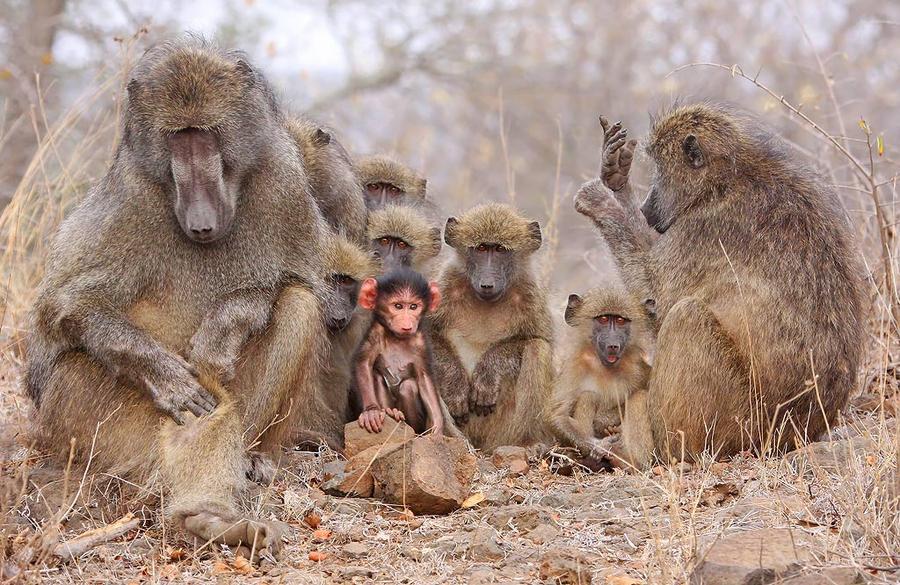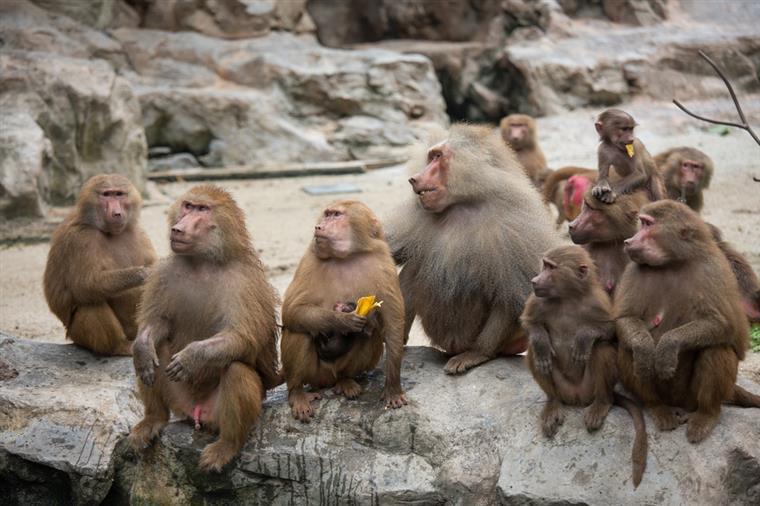The first image is the image on the left, the second image is the image on the right. For the images shown, is this caption "There are no more than two tan and brown baboons outside on grass and dirt." true? Answer yes or no. No. 